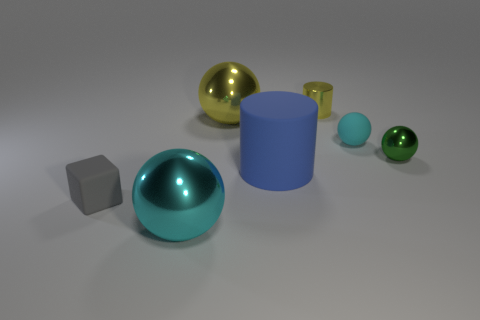There is a metallic sphere that is in front of the yellow metal ball and behind the cyan metal object; what size is it?
Keep it short and to the point. Small. What number of other blue cylinders have the same material as the small cylinder?
Your response must be concise. 0. How many cylinders are small gray things or green objects?
Ensure brevity in your answer.  0. There is a cyan object right of the large metal sphere behind the cyan ball that is on the right side of the big matte object; how big is it?
Your response must be concise. Small. There is a small object that is to the right of the tiny yellow object and behind the tiny green sphere; what color is it?
Ensure brevity in your answer.  Cyan. Does the gray thing have the same size as the cylinder that is in front of the small green shiny ball?
Ensure brevity in your answer.  No. Is there any other thing that is the same shape as the tiny gray object?
Your response must be concise. No. There is a small matte thing that is the same shape as the large cyan metal thing; what color is it?
Make the answer very short. Cyan. Is the size of the yellow shiny cylinder the same as the cyan matte object?
Ensure brevity in your answer.  Yes. What number of other objects are there of the same size as the blue object?
Offer a terse response. 2. 